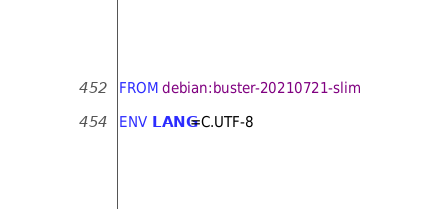Convert code to text. <code><loc_0><loc_0><loc_500><loc_500><_Dockerfile_>FROM debian:buster-20210721-slim

ENV LANG=C.UTF-8
</code> 